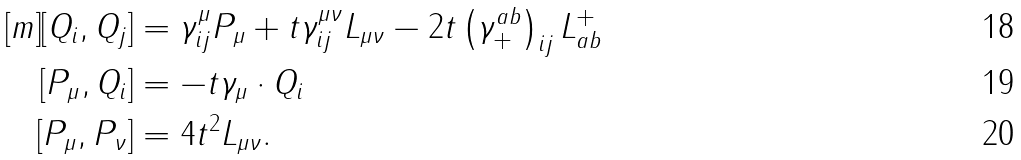Convert formula to latex. <formula><loc_0><loc_0><loc_500><loc_500>[ m ] [ Q _ { i } , Q _ { j } ] & = \gamma ^ { \mu } _ { i j } P _ { \mu } + t \gamma ^ { \mu \nu } _ { i j } L _ { \mu \nu } - 2 t \left ( \gamma ^ { a b } _ { + } \right ) _ { i j } L _ { a b } ^ { + } \\ [ P _ { \mu } , Q _ { i } ] & = - t \gamma _ { \mu } \cdot Q _ { i } \\ [ P _ { \mu } , P _ { \nu } ] & = 4 t ^ { 2 } L _ { \mu \nu } .</formula> 